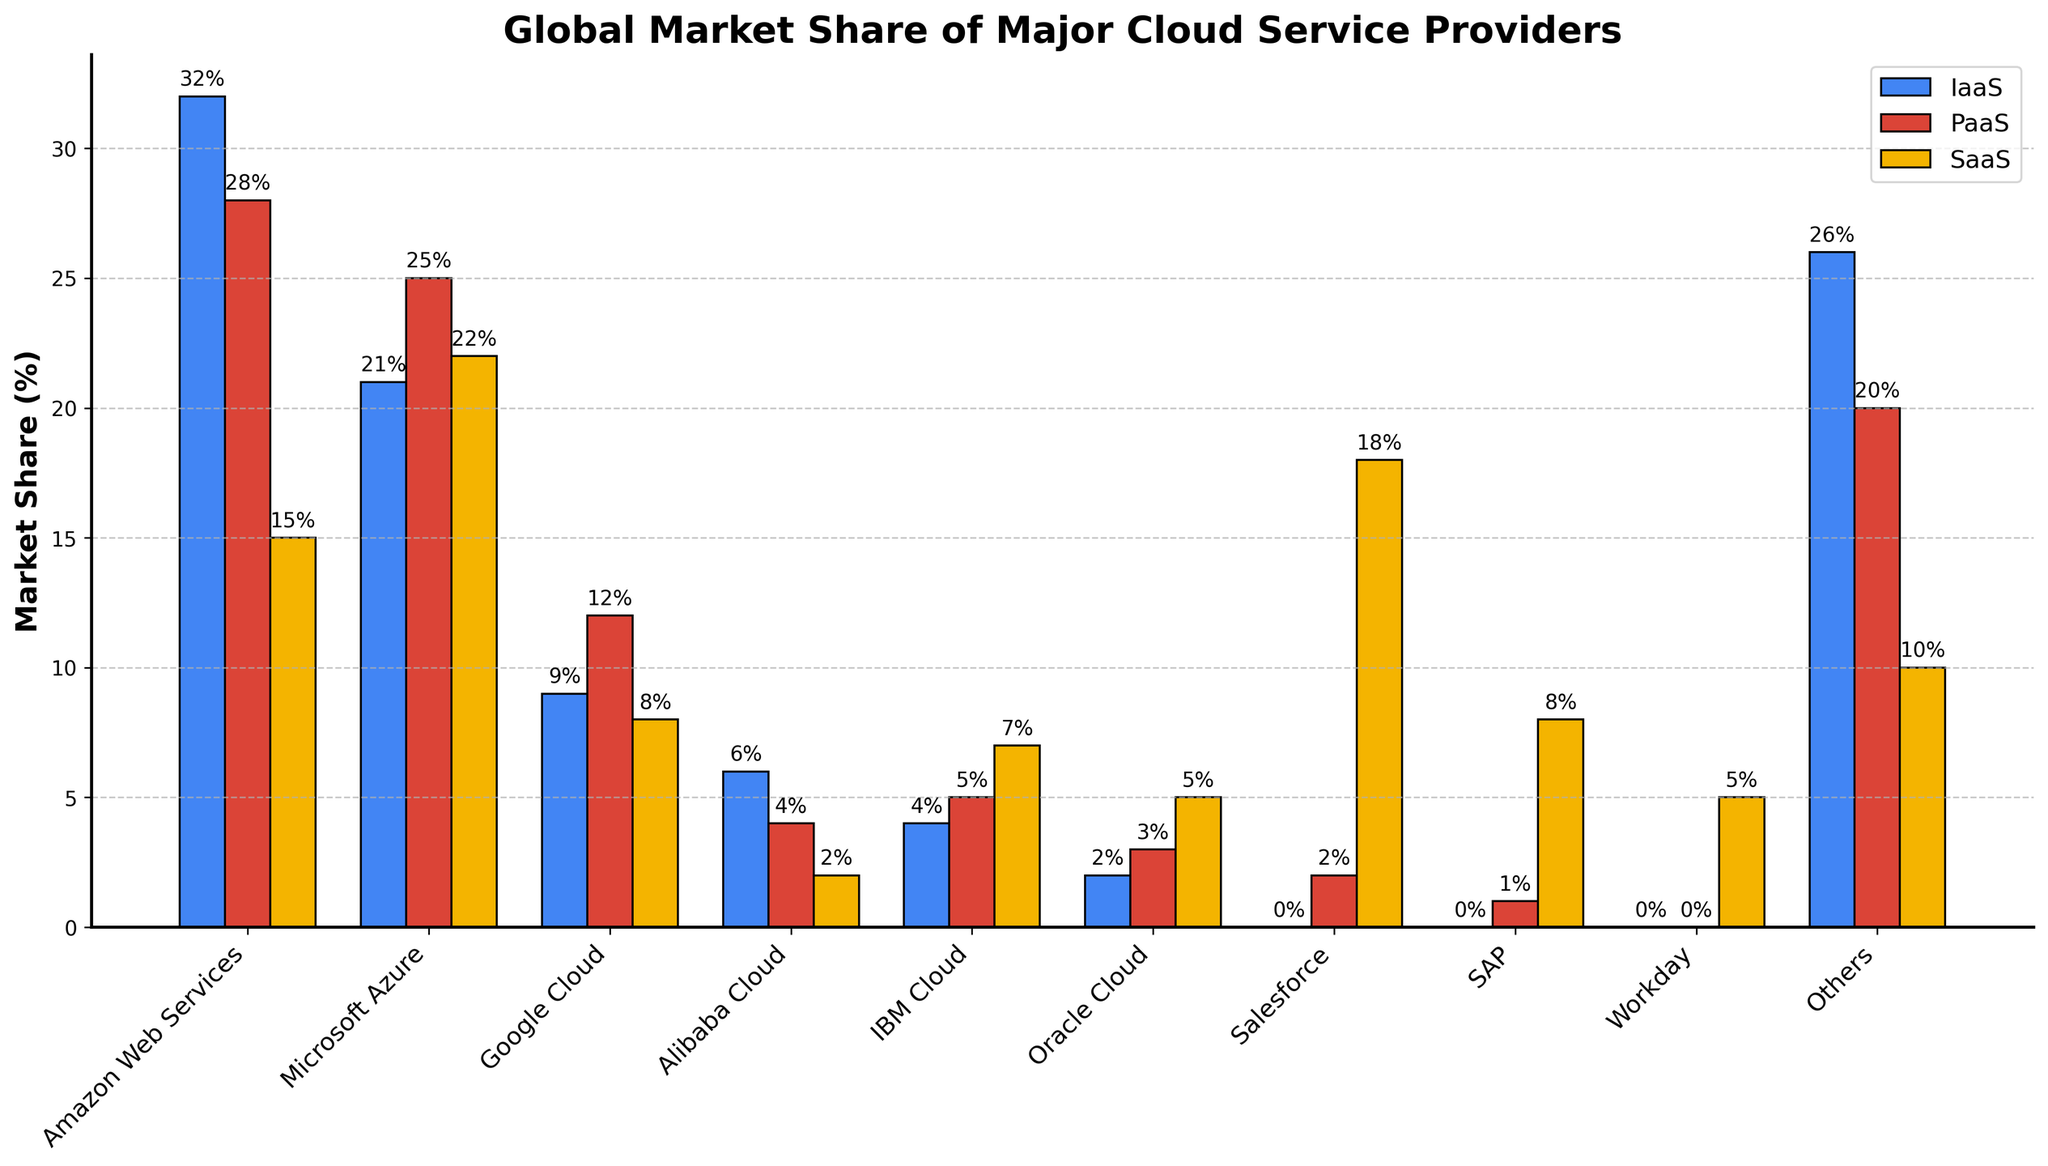Which cloud provider has the highest overall market share for PaaS? By looking at the bar heights in the PaaS category (red bars), Microsoft Azure's bar is the tallest.
Answer: Microsoft Azure What is the difference in IaaS market share between Amazon Web Services and Google Cloud? The bar for Amazon Web Services (blue) is 32%, and the bar for Google Cloud (blue) is 9%. The difference is 32% - 9%.
Answer: 23% Which cloud provider has the smallest market share in the SaaS category? Looking at the yellow bars for SaaS, Workday has the smallest bar with a 5% market share.
Answer: Workday How does the total market share of Salesforce compare to IBM Cloud? Comparing the total market shares, Salesforce has 7%, while IBM Cloud has 5%. Therefore, Salesforce has a higher total market share than IBM Cloud by 2%.
Answer: Salesforce by 2% What is the combined market share of IaaS provided by Alibaba Cloud and Oracle Cloud? The blue bar for Alibaba Cloud is 6%, and for Oracle Cloud, it is 2%. Summed together, their combined market share is 6% + 2%.
Answer: 8% Which cloud providers do not have any market share in IaaS? SAP and Workday lack blue bars for IaaS, indicating they have 0% in this category.
Answer: SAP, Workday In the SaaS category, how much higher is Salesforce's market share compared to Google Cloud? The yellow bar for Salesforce is 18%, and the yellow bar for Google Cloud is 8%. The difference is 18% - 8%.
Answer: 10% If you sum up the PaaS market share of Salesforce and SAP, what do you get? The red bar for Salesforce is 2%, and for SAP, it is 1%. Summing these, we get 2% + 1%.
Answer: 3% Which cloud providers have exactly the same total market share? Alibaba Cloud and IBM Cloud both have a total market share of 5%, as shown in the final columns of their respective entries.
Answer: Alibaba Cloud, IBM Cloud What percentage of the total market share in IaaS is held by companies other than Amazon Web Services, Microsoft Azure, and Google Cloud? Companies other than Amazon Web Services, Microsoft Azure, and Google Cloud hold 100% - (32% + 21% + 9%) = 38% in IaaS.
Answer: 38% 